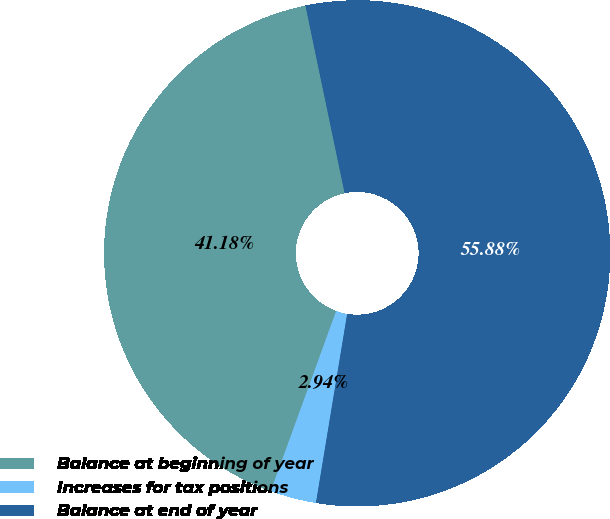Convert chart. <chart><loc_0><loc_0><loc_500><loc_500><pie_chart><fcel>Balance at beginning of year<fcel>Increases for tax positions<fcel>Balance at end of year<nl><fcel>41.18%<fcel>2.94%<fcel>55.88%<nl></chart> 